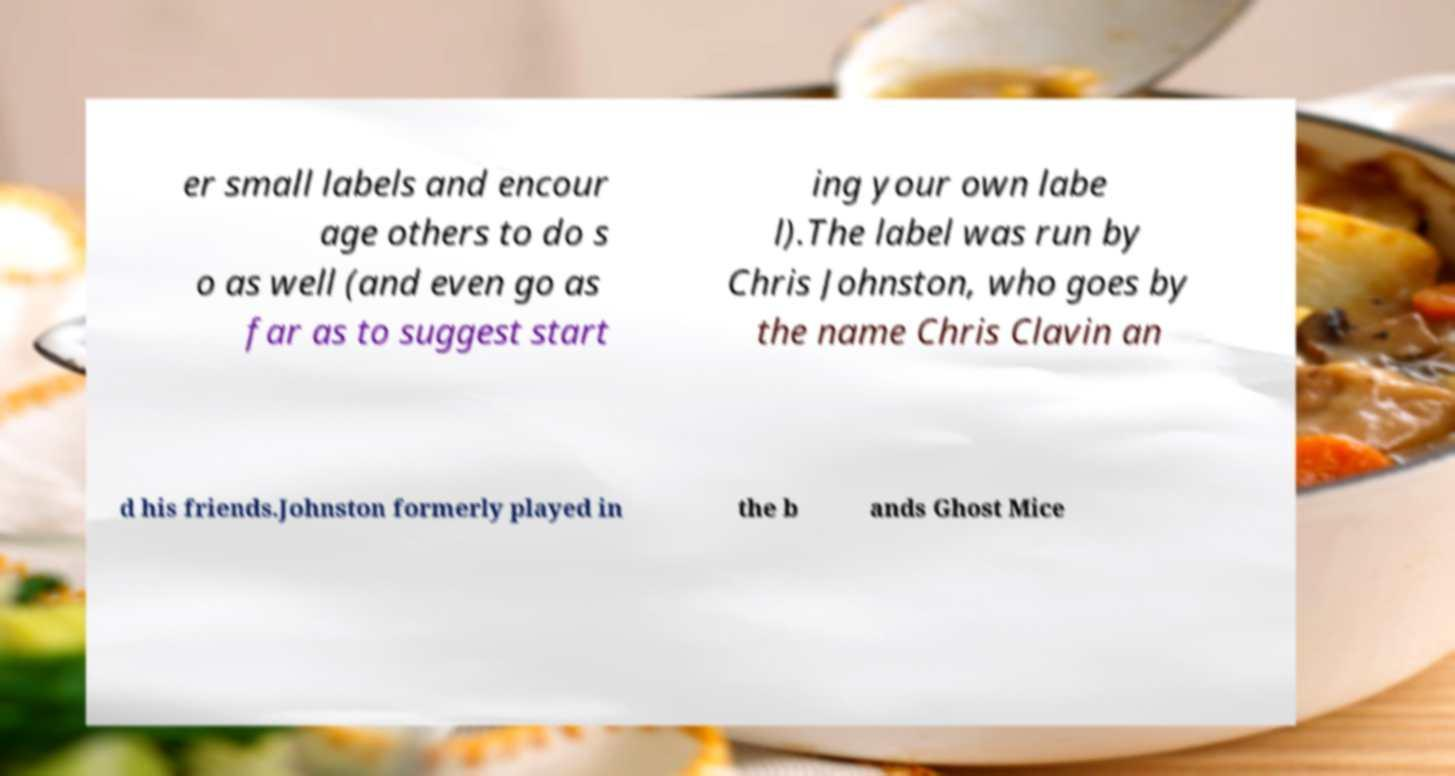Could you extract and type out the text from this image? er small labels and encour age others to do s o as well (and even go as far as to suggest start ing your own labe l).The label was run by Chris Johnston, who goes by the name Chris Clavin an d his friends.Johnston formerly played in the b ands Ghost Mice 